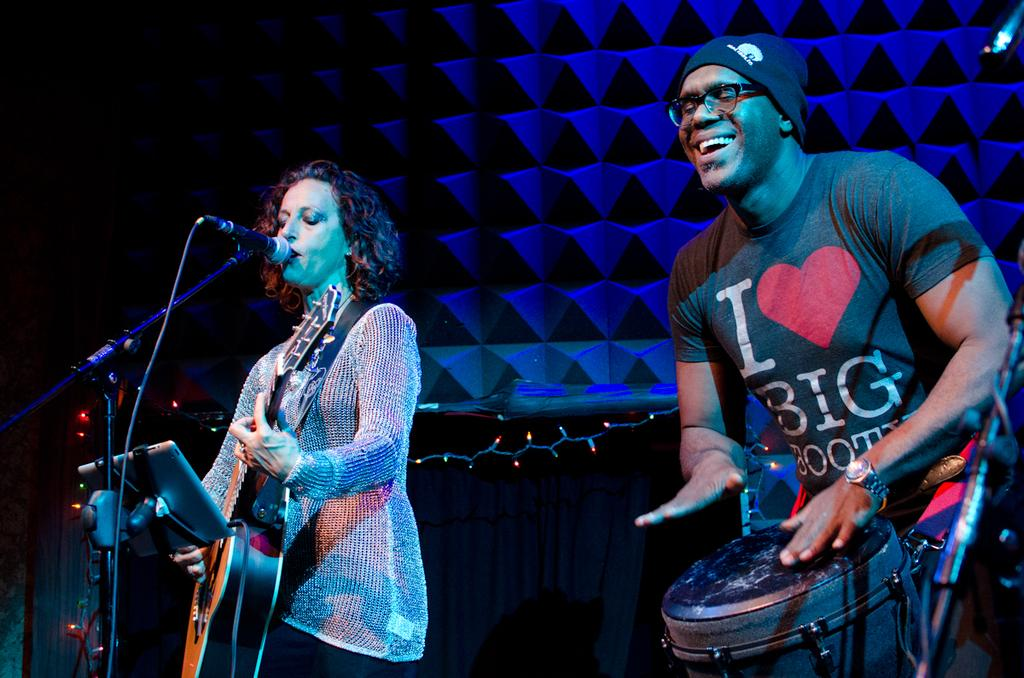How many people are in the image? There are two people in the image. What is the man doing in the image? The man is playing a musical instrument. What device is present for amplifying sound in the image? There is a microphone (mic) in the image. What object is used to support or hold something in the image? There is a stand in the image. How many fangs can be seen on the dolls in the image? There are no dolls or fangs present in the image. What type of owl is sitting on the stand in the image? There is no owl present in the image; the stand is used to support or hold something else. 